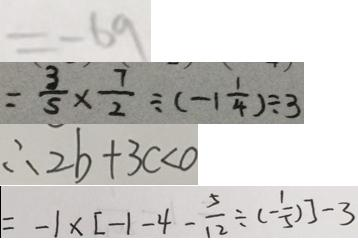Convert formula to latex. <formula><loc_0><loc_0><loc_500><loc_500>= - 6 9 
 = \frac { 3 } { 5 } \times \frac { 7 } { 2 } \div ( - 1 \frac { 1 } { 4 } ) \div 3 
 \therefore 2 b + 3 c < 0 
 = - 1 \times [ - 1 - 4 - \frac { 5 } { 1 2 } \div ( - \frac { 1 } { 5 } ) ] - 3</formula> 